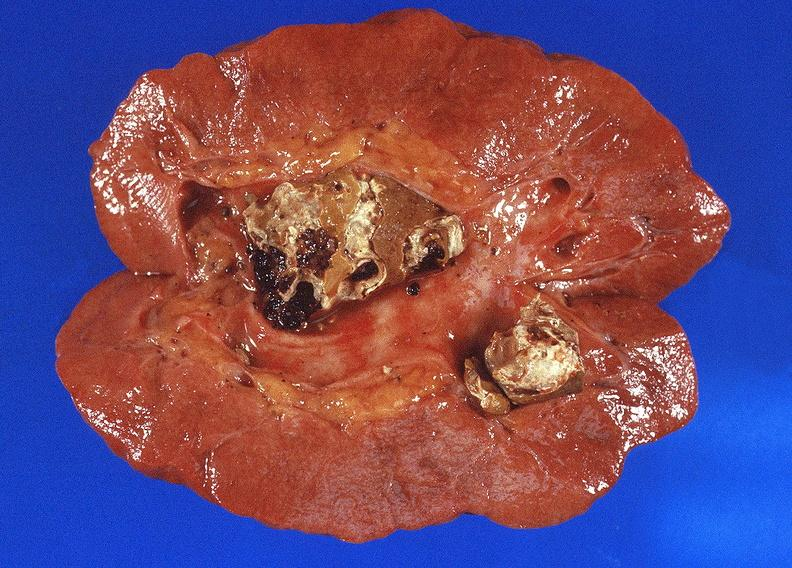does palmar crease normal show staghorn calculi in renal pelvis, gout?
Answer the question using a single word or phrase. No 